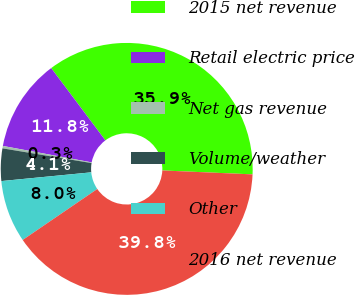Convert chart to OTSL. <chart><loc_0><loc_0><loc_500><loc_500><pie_chart><fcel>2015 net revenue<fcel>Retail electric price<fcel>Net gas revenue<fcel>Volume/weather<fcel>Other<fcel>2016 net revenue<nl><fcel>35.93%<fcel>11.85%<fcel>0.31%<fcel>4.15%<fcel>8.0%<fcel>39.77%<nl></chart> 